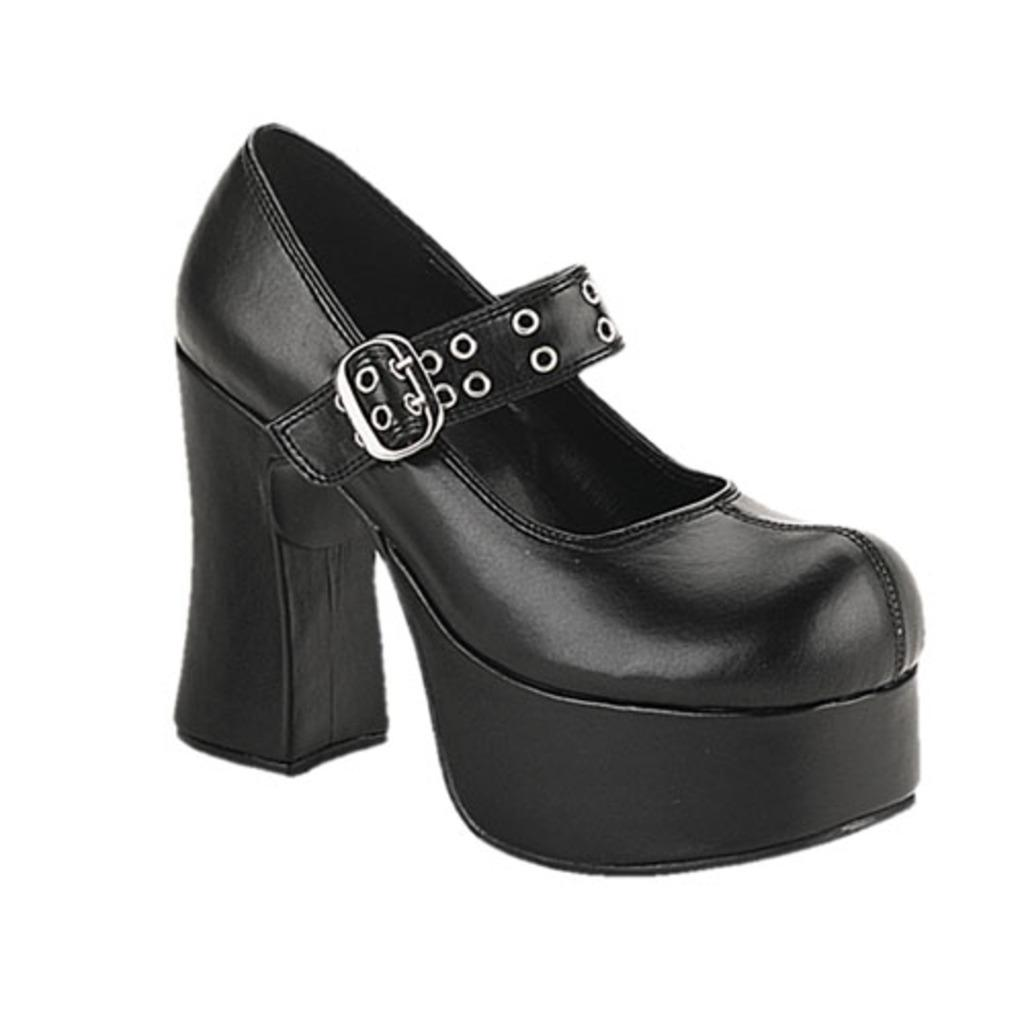What type of object is present in the image? There is footwear in the image. Can you describe the color of the footwear? The footwear is black in color. Where can we find the zoo in the image? There is no zoo present in the image. What type of food is being prepared in the image? There is no food preparation visible in the image; it only features footwear. 